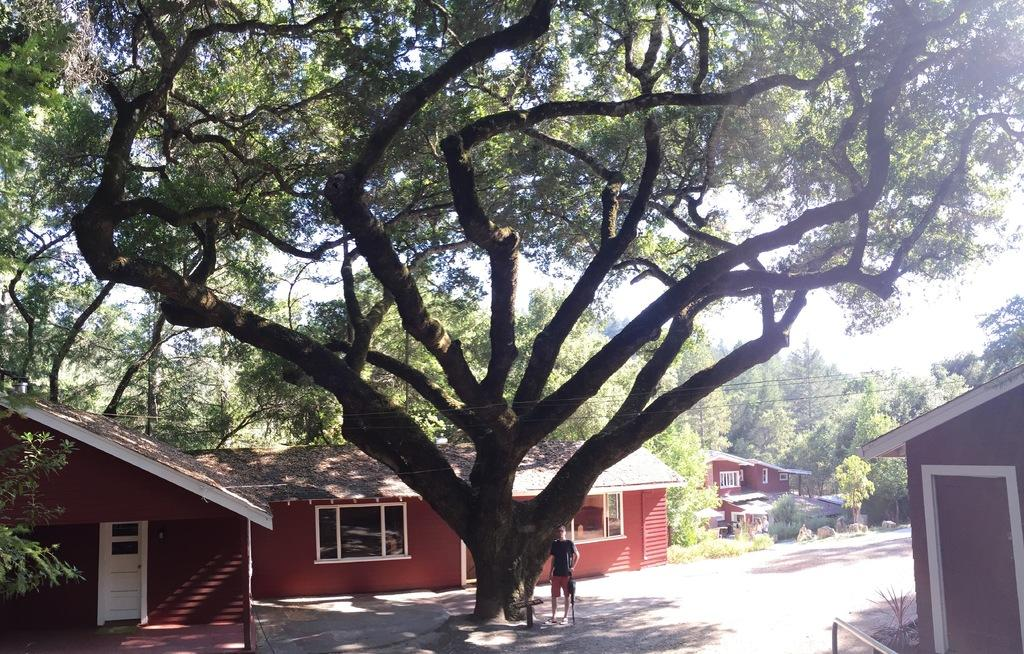What is the main subject of the image? There is a person standing on the road in the image. What can be seen in the background of the image? Trees, wooden houses, and the sky are visible in the background of the image. How many bubbles are floating around the person in the image? There are no bubbles present in the image. What type of amusement park can be seen in the background of the image? There is no amusement park visible in the image; it features a person standing on the road with trees, wooden houses, and the sky in the background. 